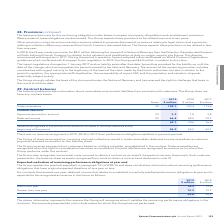According to Spirent Communications Plc's financial document, When are trade receivables recognised? when the right to consideration becomes unconditional. The document states: "in the contract. Trade receivables are recognised when the right to consideration becomes unconditional. Contract liabilities are recognised as revenu..." Also, On what basis does the Group receive payments from customers? based on a billing schedule, as established in the contract. The document states: "The Group receives payments from customers based on a billing schedule, as established in the contract. Trade receivables are recognised when the righ..." Also, For which years does the table provide information about receivables and contract liabilities from contracts with customers? The document contains multiple relevant values: 2019, 2018, 2017. From the document: "2019 2018 2017 Notes $ million $ million $ million 2019 2018 2017 Notes $ million $ million $ million 2019 2018 2017 Notes $ million $ million $ milli..." Additionally, In which year was the amount of deferred income the largest? According to the financial document, 2017. The relevant text states: "2019 2018 2017 Notes $ million $ million $ million..." Also, can you calculate: What was the change in trade receivables in 2019 from 2018? Based on the calculation: 128.7-123.4, the result is 5.3 (in millions). This is based on the information: "Trade receivables 20 128.7 123.4 113.8 Trade receivables 20 128.7 123.4 113.8..." The key data points involved are: 123.4, 128.7. Also, can you calculate: What was the percentage change in trade receivables in 2019 from 2018? To answer this question, I need to perform calculations using the financial data. The calculation is: (128.7-123.4)/123.4, which equals 4.29 (percentage). This is based on the information: "Trade receivables 20 128.7 123.4 113.8 Trade receivables 20 128.7 123.4 113.8..." The key data points involved are: 123.4, 128.7. 